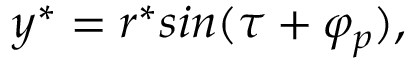<formula> <loc_0><loc_0><loc_500><loc_500>y ^ { * } = r ^ { * } \sin ( \tau + \varphi _ { p } ) ,</formula> 